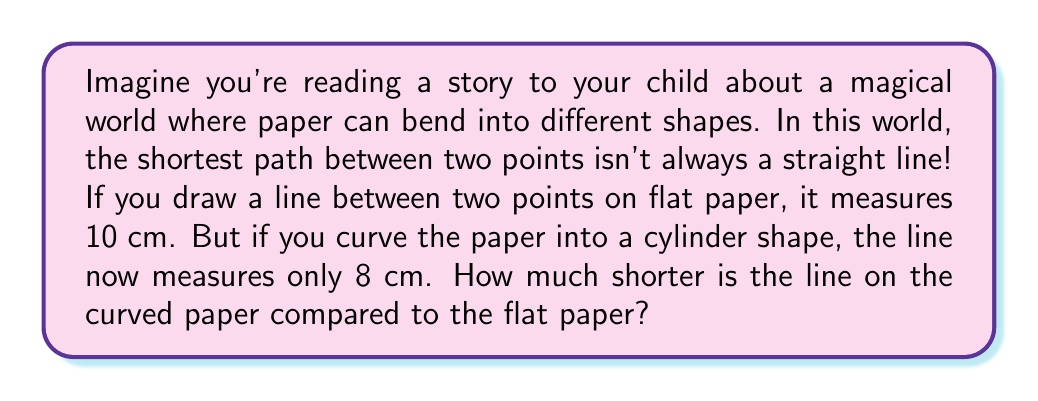Can you answer this question? Let's break this down into simple steps:

1. First, we need to understand what the question is asking:
   - On flat paper, the line is 10 cm long
   - On curved paper (cylinder), the line is 8 cm long
   - We need to find out how much shorter the curved line is

2. To find the difference, we subtract the curved line length from the flat line length:
   $$ \text{Difference} = \text{Flat line length} - \text{Curved line length} $$
   $$ \text{Difference} = 10 \text{ cm} - 8 \text{ cm} = 2 \text{ cm} $$

3. So, the line on the curved paper is 2 cm shorter than the line on flat paper.

This demonstrates that on curved surfaces, like in non-Euclidean geometry, the shortest path between two points can be different from what we expect on a flat surface!
Answer: 2 cm 